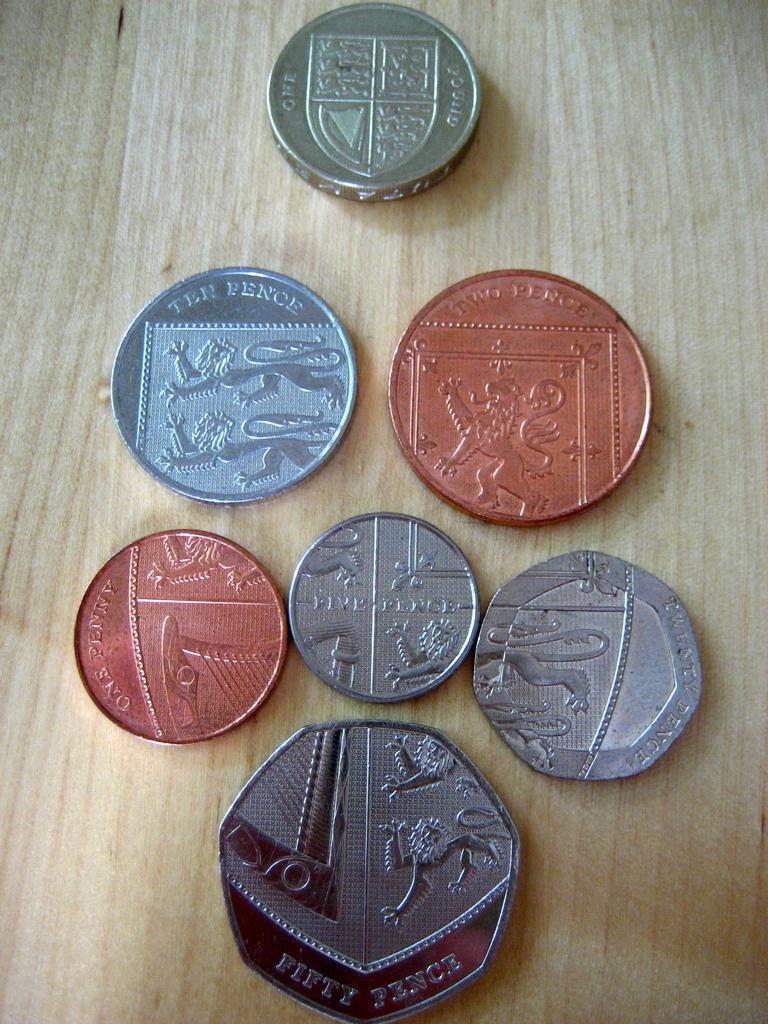What is the value of the coin in the middle?
Your answer should be compact. Five pence. How many pence is on the bottom of all the coins?
Provide a succinct answer. Fifty. 